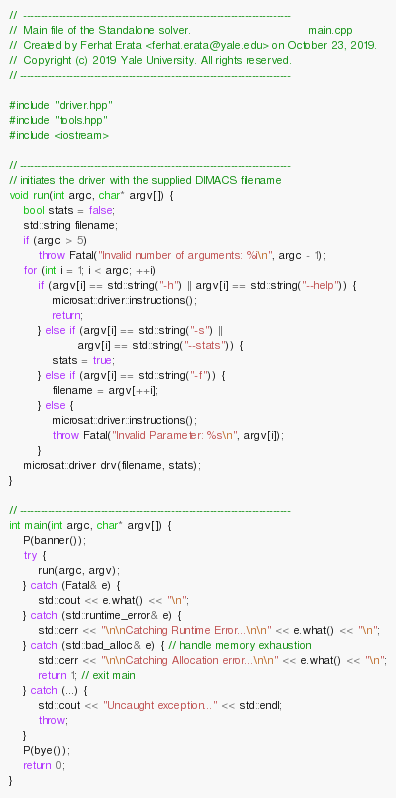Convert code to text. <code><loc_0><loc_0><loc_500><loc_500><_C++_>//  ----------------------------------------------------------------------------
//  Main file of the Standalone solver.                                 main.cpp
//  Created by Ferhat Erata <ferhat.erata@yale.edu> on October 23, 2019.
//  Copyright (c) 2019 Yale University. All rights reserved.
// -----------------------------------------------------------------------------

#include "driver.hpp"
#include "tools.hpp"
#include <iostream>

// -----------------------------------------------------------------------------
// initiates the driver with the supplied DIMACS filename
void run(int argc, char* argv[]) {
    bool stats = false;
    std::string filename;
    if (argc > 5)
        throw Fatal("Invalid number of arguments: %i\n", argc - 1);
    for (int i = 1; i < argc; ++i)
        if (argv[i] == std::string("-h") || argv[i] == std::string("--help")) {
            microsat::driver::instructions();
            return;
        } else if (argv[i] == std::string("-s") ||
                   argv[i] == std::string("--stats")) {
            stats = true;
        } else if (argv[i] == std::string("-f")) {
            filename = argv[++i];
        } else {
            microsat::driver::instructions();
            throw Fatal("Invalid Parameter: %s\n", argv[i]);
        }
    microsat::driver drv(filename, stats);
}

// -----------------------------------------------------------------------------
int main(int argc, char* argv[]) {
    P(banner());
    try {
        run(argc, argv);
    } catch (Fatal& e) {
        std::cout << e.what() << "\n";
    } catch (std::runtime_error& e) {
        std::cerr << "\n\nCatching Runtime Error...\n\n" << e.what() << "\n";
    } catch (std::bad_alloc& e) { // handle memory exhaustion
        std::cerr << "\n\nCatching Allocation error...\n\n" << e.what() << "\n";
        return 1; // exit main
    } catch (...) {
        std::cout << "Uncaught exception..." << std::endl;
        throw;
    }
    P(bye());
    return 0;
}
</code> 